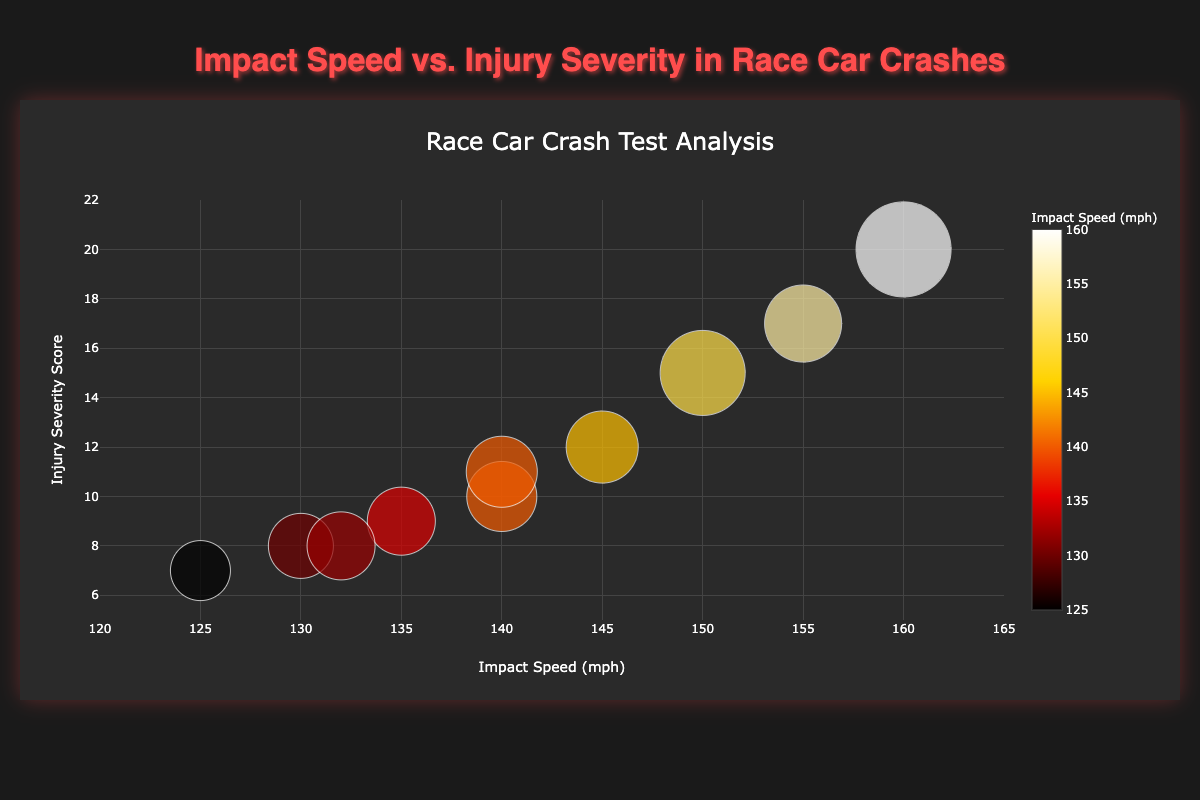What is the title of the figure? The title of the figure is prominently displayed at the top.
Answer: Race Car Crash Test Analysis How many race car models are represented in the chart? Each bubble represents a race car model. There are 10 bubbles in the chart.
Answer: 10 What is the range of the impact speed on the x-axis? The x-axis ranges from 120 to 165 mph, as indicated by the tick marks and labels.
Answer: 120 to 165 mph Which race car model has the highest injury severity score? By examining the highest point on the y-axis, we see that the Red Bull RB16B has the highest injury severity score of 20.
Answer: Red Bull RB16B What is the injury severity score for the Aston Martin AMR21? Locate the bubble for Aston Martin AMR21, which corresponds to an injury severity score of 12 on the y-axis.
Answer: 12 Which race car model has the lowest impact speed, and what is that speed? The lowest point on the x-axis is associated with the Alfa Romeo C41, which has an impact speed of 125 mph.
Answer: Alfa Romeo C41, 125 mph Which race car model has the highest car damage cost, and how much is it? The size of the bubbles represents the car damage cost. The largest bubble is for the Red Bull RB16B, with a damage cost of $95k.
Answer: Red Bull RB16B, $95k What is the difference in injury severity score between the Ferrari SF21 and the McLaren MCL35M? The injury severity score for Ferrari SF21 is 15, and for McLaren MCL35M, it is 8. The difference is 15 - 8 = 7.
Answer: 7 What is the average injury severity score for the cars with an impact speed of 140 mph? The cars with an impact speed of 140 mph are Mercedes W12 and Haas VF-21, with injury severity scores of 10 and 11. The average is (10 + 11) / 2 = 10.5.
Answer: 10.5 Which race car model has the closest injury severity score to 10? The race car models close to an injury severity score of 10 are Mercedes W12 with an injury severity score of 10 and Haas VF-21 with a score of 11. Mercedes W12 is the closest.
Answer: Mercedes W12 